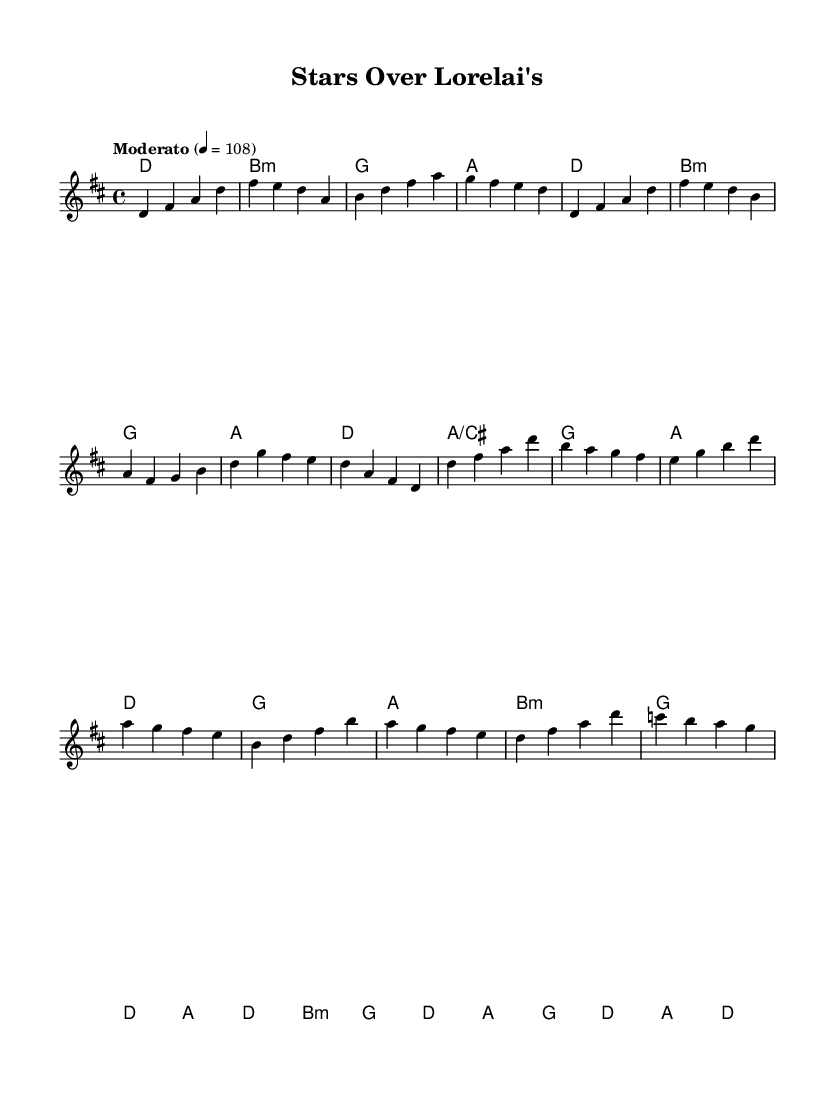What is the key signature of this music? The key signature is D major, which has two sharps (F# and C#). This can be determined by looking at the key signature located at the beginning of the staff where it indicates D major.
Answer: D major What is the time signature used in this piece? The time signature is 4/4, which is indicated at the beginning of the score. It signifies that there are four beats in each measure and the quarter note gets one beat.
Answer: 4/4 What is the tempo marking for this piece? The tempo marking for the piece is Moderato, which is notated at the beginning of the score along with a metronome marking of 108 beats per minute. This indicates a moderately paced music.
Answer: Moderato How many measures are in the Chorus section? The Chorus section consists of four measures, which can be counted by identifying the section labeled as the Chorus and counting the bar lines within that segment.
Answer: 4 What is the first chord in the piece? The first chord in the piece is D major, which can be identified in the harmonies section under the Intro, where the chord is indicated by the symbol 'd'.
Answer: D major What is the last note of the melody? The last note of the melody is G, which is found at the end of the melody line in the Bridge section. Counting the notes in the Bridge, the last note is clearly marked as G.
Answer: G How many different chords are employed in the Verse section? There are five different chords used in the Verse section: D, B minor, G, A, and A/C#. By reviewing the harmonies indicated under the Verse, each unique chord can be identified.
Answer: 5 